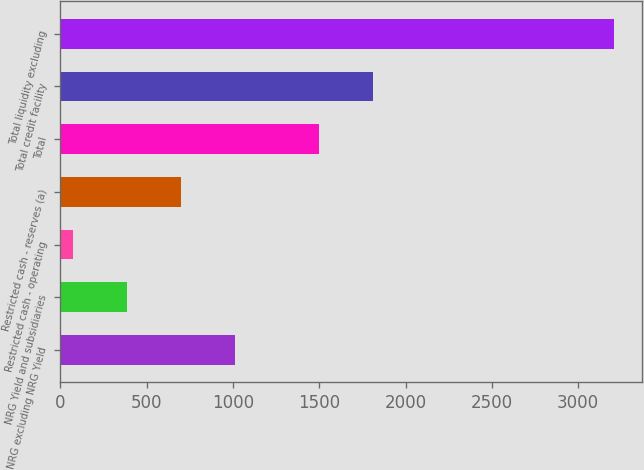Convert chart. <chart><loc_0><loc_0><loc_500><loc_500><bar_chart><fcel>NRG excluding NRG Yield<fcel>NRG Yield and subsidiaries<fcel>Restricted cash - operating<fcel>Restricted cash - reserves (a)<fcel>Total<fcel>Total credit facility<fcel>Total liquidity excluding<nl><fcel>1012.7<fcel>384.9<fcel>71<fcel>698.8<fcel>1499<fcel>1812.9<fcel>3210<nl></chart> 